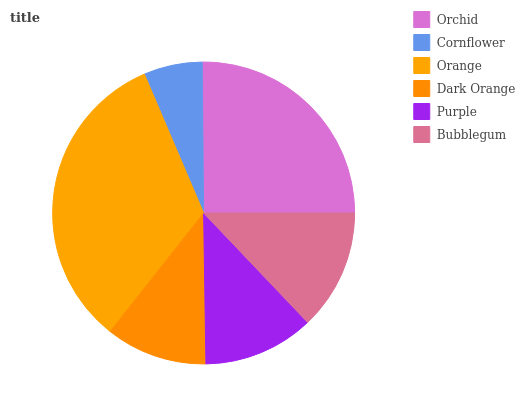Is Cornflower the minimum?
Answer yes or no. Yes. Is Orange the maximum?
Answer yes or no. Yes. Is Orange the minimum?
Answer yes or no. No. Is Cornflower the maximum?
Answer yes or no. No. Is Orange greater than Cornflower?
Answer yes or no. Yes. Is Cornflower less than Orange?
Answer yes or no. Yes. Is Cornflower greater than Orange?
Answer yes or no. No. Is Orange less than Cornflower?
Answer yes or no. No. Is Bubblegum the high median?
Answer yes or no. Yes. Is Purple the low median?
Answer yes or no. Yes. Is Orange the high median?
Answer yes or no. No. Is Cornflower the low median?
Answer yes or no. No. 